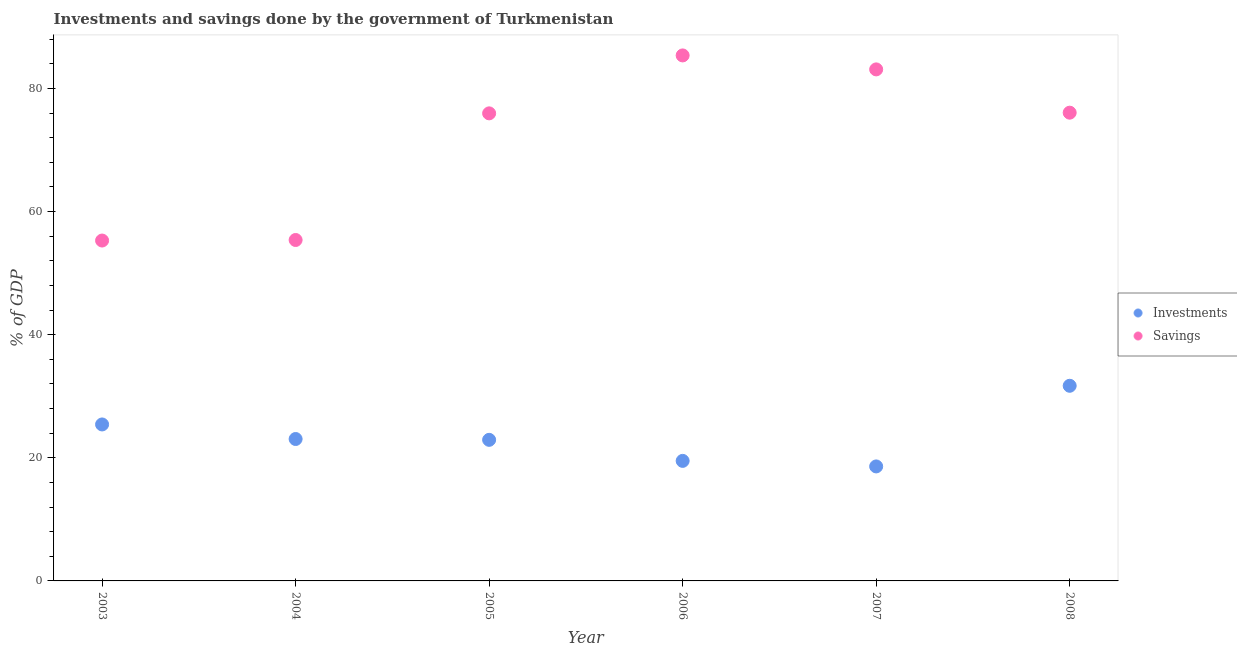Is the number of dotlines equal to the number of legend labels?
Offer a very short reply. Yes. What is the savings of government in 2008?
Provide a succinct answer. 76.06. Across all years, what is the maximum investments of government?
Provide a short and direct response. 31.7. In which year was the savings of government maximum?
Ensure brevity in your answer.  2006. In which year was the investments of government minimum?
Your answer should be very brief. 2007. What is the total savings of government in the graph?
Provide a short and direct response. 431.16. What is the difference between the savings of government in 2005 and that in 2008?
Provide a succinct answer. -0.11. What is the difference between the savings of government in 2006 and the investments of government in 2004?
Give a very brief answer. 62.31. What is the average investments of government per year?
Ensure brevity in your answer.  23.53. In the year 2005, what is the difference between the savings of government and investments of government?
Offer a terse response. 53.04. What is the ratio of the investments of government in 2007 to that in 2008?
Keep it short and to the point. 0.59. Is the difference between the investments of government in 2004 and 2006 greater than the difference between the savings of government in 2004 and 2006?
Your response must be concise. Yes. What is the difference between the highest and the second highest savings of government?
Make the answer very short. 2.27. What is the difference between the highest and the lowest investments of government?
Give a very brief answer. 13.1. Does the savings of government monotonically increase over the years?
Offer a very short reply. No. Is the investments of government strictly greater than the savings of government over the years?
Offer a terse response. No. How many dotlines are there?
Give a very brief answer. 2. How many years are there in the graph?
Make the answer very short. 6. Does the graph contain any zero values?
Give a very brief answer. No. Where does the legend appear in the graph?
Provide a succinct answer. Center right. How many legend labels are there?
Offer a very short reply. 2. What is the title of the graph?
Provide a succinct answer. Investments and savings done by the government of Turkmenistan. Does "Highest 10% of population" appear as one of the legend labels in the graph?
Your response must be concise. No. What is the label or title of the X-axis?
Make the answer very short. Year. What is the label or title of the Y-axis?
Ensure brevity in your answer.  % of GDP. What is the % of GDP of Investments in 2003?
Provide a short and direct response. 25.42. What is the % of GDP in Savings in 2003?
Provide a succinct answer. 55.29. What is the % of GDP of Investments in 2004?
Keep it short and to the point. 23.05. What is the % of GDP of Savings in 2004?
Your response must be concise. 55.38. What is the % of GDP in Investments in 2005?
Ensure brevity in your answer.  22.92. What is the % of GDP of Savings in 2005?
Keep it short and to the point. 75.96. What is the % of GDP of Investments in 2006?
Make the answer very short. 19.5. What is the % of GDP of Savings in 2006?
Ensure brevity in your answer.  85.37. What is the % of GDP in Savings in 2007?
Provide a succinct answer. 83.1. What is the % of GDP in Investments in 2008?
Your answer should be very brief. 31.7. What is the % of GDP of Savings in 2008?
Your answer should be compact. 76.06. Across all years, what is the maximum % of GDP of Investments?
Offer a very short reply. 31.7. Across all years, what is the maximum % of GDP of Savings?
Give a very brief answer. 85.37. Across all years, what is the minimum % of GDP of Investments?
Keep it short and to the point. 18.6. Across all years, what is the minimum % of GDP in Savings?
Make the answer very short. 55.29. What is the total % of GDP in Investments in the graph?
Make the answer very short. 141.19. What is the total % of GDP of Savings in the graph?
Keep it short and to the point. 431.16. What is the difference between the % of GDP in Investments in 2003 and that in 2004?
Provide a short and direct response. 2.37. What is the difference between the % of GDP in Savings in 2003 and that in 2004?
Give a very brief answer. -0.09. What is the difference between the % of GDP in Investments in 2003 and that in 2005?
Ensure brevity in your answer.  2.5. What is the difference between the % of GDP of Savings in 2003 and that in 2005?
Make the answer very short. -20.66. What is the difference between the % of GDP of Investments in 2003 and that in 2006?
Keep it short and to the point. 5.92. What is the difference between the % of GDP of Savings in 2003 and that in 2006?
Offer a terse response. -30.07. What is the difference between the % of GDP in Investments in 2003 and that in 2007?
Ensure brevity in your answer.  6.82. What is the difference between the % of GDP in Savings in 2003 and that in 2007?
Provide a succinct answer. -27.8. What is the difference between the % of GDP of Investments in 2003 and that in 2008?
Your response must be concise. -6.28. What is the difference between the % of GDP of Savings in 2003 and that in 2008?
Give a very brief answer. -20.77. What is the difference between the % of GDP in Investments in 2004 and that in 2005?
Make the answer very short. 0.14. What is the difference between the % of GDP of Savings in 2004 and that in 2005?
Offer a terse response. -20.57. What is the difference between the % of GDP in Investments in 2004 and that in 2006?
Give a very brief answer. 3.55. What is the difference between the % of GDP in Savings in 2004 and that in 2006?
Your answer should be compact. -29.98. What is the difference between the % of GDP of Investments in 2004 and that in 2007?
Provide a succinct answer. 4.45. What is the difference between the % of GDP of Savings in 2004 and that in 2007?
Your answer should be compact. -27.71. What is the difference between the % of GDP in Investments in 2004 and that in 2008?
Offer a terse response. -8.65. What is the difference between the % of GDP of Savings in 2004 and that in 2008?
Give a very brief answer. -20.68. What is the difference between the % of GDP in Investments in 2005 and that in 2006?
Your answer should be very brief. 3.42. What is the difference between the % of GDP of Savings in 2005 and that in 2006?
Keep it short and to the point. -9.41. What is the difference between the % of GDP in Investments in 2005 and that in 2007?
Give a very brief answer. 4.32. What is the difference between the % of GDP in Savings in 2005 and that in 2007?
Your answer should be compact. -7.14. What is the difference between the % of GDP in Investments in 2005 and that in 2008?
Give a very brief answer. -8.78. What is the difference between the % of GDP of Savings in 2005 and that in 2008?
Offer a terse response. -0.11. What is the difference between the % of GDP of Investments in 2006 and that in 2007?
Make the answer very short. 0.9. What is the difference between the % of GDP of Savings in 2006 and that in 2007?
Make the answer very short. 2.27. What is the difference between the % of GDP in Investments in 2006 and that in 2008?
Ensure brevity in your answer.  -12.2. What is the difference between the % of GDP of Savings in 2006 and that in 2008?
Offer a very short reply. 9.3. What is the difference between the % of GDP of Savings in 2007 and that in 2008?
Your answer should be very brief. 7.03. What is the difference between the % of GDP in Investments in 2003 and the % of GDP in Savings in 2004?
Your response must be concise. -29.96. What is the difference between the % of GDP of Investments in 2003 and the % of GDP of Savings in 2005?
Keep it short and to the point. -50.54. What is the difference between the % of GDP of Investments in 2003 and the % of GDP of Savings in 2006?
Keep it short and to the point. -59.95. What is the difference between the % of GDP in Investments in 2003 and the % of GDP in Savings in 2007?
Ensure brevity in your answer.  -57.68. What is the difference between the % of GDP in Investments in 2003 and the % of GDP in Savings in 2008?
Give a very brief answer. -50.65. What is the difference between the % of GDP of Investments in 2004 and the % of GDP of Savings in 2005?
Your answer should be compact. -52.9. What is the difference between the % of GDP in Investments in 2004 and the % of GDP in Savings in 2006?
Provide a succinct answer. -62.31. What is the difference between the % of GDP of Investments in 2004 and the % of GDP of Savings in 2007?
Offer a very short reply. -60.04. What is the difference between the % of GDP of Investments in 2004 and the % of GDP of Savings in 2008?
Provide a succinct answer. -53.01. What is the difference between the % of GDP of Investments in 2005 and the % of GDP of Savings in 2006?
Keep it short and to the point. -62.45. What is the difference between the % of GDP of Investments in 2005 and the % of GDP of Savings in 2007?
Make the answer very short. -60.18. What is the difference between the % of GDP in Investments in 2005 and the % of GDP in Savings in 2008?
Your answer should be very brief. -53.15. What is the difference between the % of GDP in Investments in 2006 and the % of GDP in Savings in 2007?
Provide a short and direct response. -63.6. What is the difference between the % of GDP of Investments in 2006 and the % of GDP of Savings in 2008?
Provide a short and direct response. -56.56. What is the difference between the % of GDP in Investments in 2007 and the % of GDP in Savings in 2008?
Your answer should be compact. -57.46. What is the average % of GDP in Investments per year?
Ensure brevity in your answer.  23.53. What is the average % of GDP of Savings per year?
Your response must be concise. 71.86. In the year 2003, what is the difference between the % of GDP in Investments and % of GDP in Savings?
Your answer should be very brief. -29.88. In the year 2004, what is the difference between the % of GDP of Investments and % of GDP of Savings?
Give a very brief answer. -32.33. In the year 2005, what is the difference between the % of GDP of Investments and % of GDP of Savings?
Give a very brief answer. -53.04. In the year 2006, what is the difference between the % of GDP in Investments and % of GDP in Savings?
Your response must be concise. -65.87. In the year 2007, what is the difference between the % of GDP in Investments and % of GDP in Savings?
Ensure brevity in your answer.  -64.5. In the year 2008, what is the difference between the % of GDP in Investments and % of GDP in Savings?
Provide a succinct answer. -44.36. What is the ratio of the % of GDP of Investments in 2003 to that in 2004?
Your answer should be very brief. 1.1. What is the ratio of the % of GDP of Investments in 2003 to that in 2005?
Provide a short and direct response. 1.11. What is the ratio of the % of GDP in Savings in 2003 to that in 2005?
Provide a short and direct response. 0.73. What is the ratio of the % of GDP of Investments in 2003 to that in 2006?
Ensure brevity in your answer.  1.3. What is the ratio of the % of GDP in Savings in 2003 to that in 2006?
Your response must be concise. 0.65. What is the ratio of the % of GDP in Investments in 2003 to that in 2007?
Your answer should be very brief. 1.37. What is the ratio of the % of GDP of Savings in 2003 to that in 2007?
Provide a succinct answer. 0.67. What is the ratio of the % of GDP of Investments in 2003 to that in 2008?
Ensure brevity in your answer.  0.8. What is the ratio of the % of GDP of Savings in 2003 to that in 2008?
Your answer should be very brief. 0.73. What is the ratio of the % of GDP in Investments in 2004 to that in 2005?
Your answer should be compact. 1.01. What is the ratio of the % of GDP in Savings in 2004 to that in 2005?
Provide a succinct answer. 0.73. What is the ratio of the % of GDP of Investments in 2004 to that in 2006?
Ensure brevity in your answer.  1.18. What is the ratio of the % of GDP of Savings in 2004 to that in 2006?
Offer a terse response. 0.65. What is the ratio of the % of GDP in Investments in 2004 to that in 2007?
Your response must be concise. 1.24. What is the ratio of the % of GDP in Savings in 2004 to that in 2007?
Offer a terse response. 0.67. What is the ratio of the % of GDP of Investments in 2004 to that in 2008?
Your response must be concise. 0.73. What is the ratio of the % of GDP in Savings in 2004 to that in 2008?
Provide a succinct answer. 0.73. What is the ratio of the % of GDP of Investments in 2005 to that in 2006?
Provide a short and direct response. 1.18. What is the ratio of the % of GDP in Savings in 2005 to that in 2006?
Offer a very short reply. 0.89. What is the ratio of the % of GDP in Investments in 2005 to that in 2007?
Your response must be concise. 1.23. What is the ratio of the % of GDP in Savings in 2005 to that in 2007?
Provide a succinct answer. 0.91. What is the ratio of the % of GDP in Investments in 2005 to that in 2008?
Your response must be concise. 0.72. What is the ratio of the % of GDP of Investments in 2006 to that in 2007?
Offer a terse response. 1.05. What is the ratio of the % of GDP in Savings in 2006 to that in 2007?
Give a very brief answer. 1.03. What is the ratio of the % of GDP in Investments in 2006 to that in 2008?
Your response must be concise. 0.62. What is the ratio of the % of GDP in Savings in 2006 to that in 2008?
Give a very brief answer. 1.12. What is the ratio of the % of GDP of Investments in 2007 to that in 2008?
Offer a very short reply. 0.59. What is the ratio of the % of GDP in Savings in 2007 to that in 2008?
Ensure brevity in your answer.  1.09. What is the difference between the highest and the second highest % of GDP of Investments?
Your answer should be compact. 6.28. What is the difference between the highest and the second highest % of GDP in Savings?
Give a very brief answer. 2.27. What is the difference between the highest and the lowest % of GDP of Investments?
Ensure brevity in your answer.  13.1. What is the difference between the highest and the lowest % of GDP of Savings?
Provide a succinct answer. 30.07. 